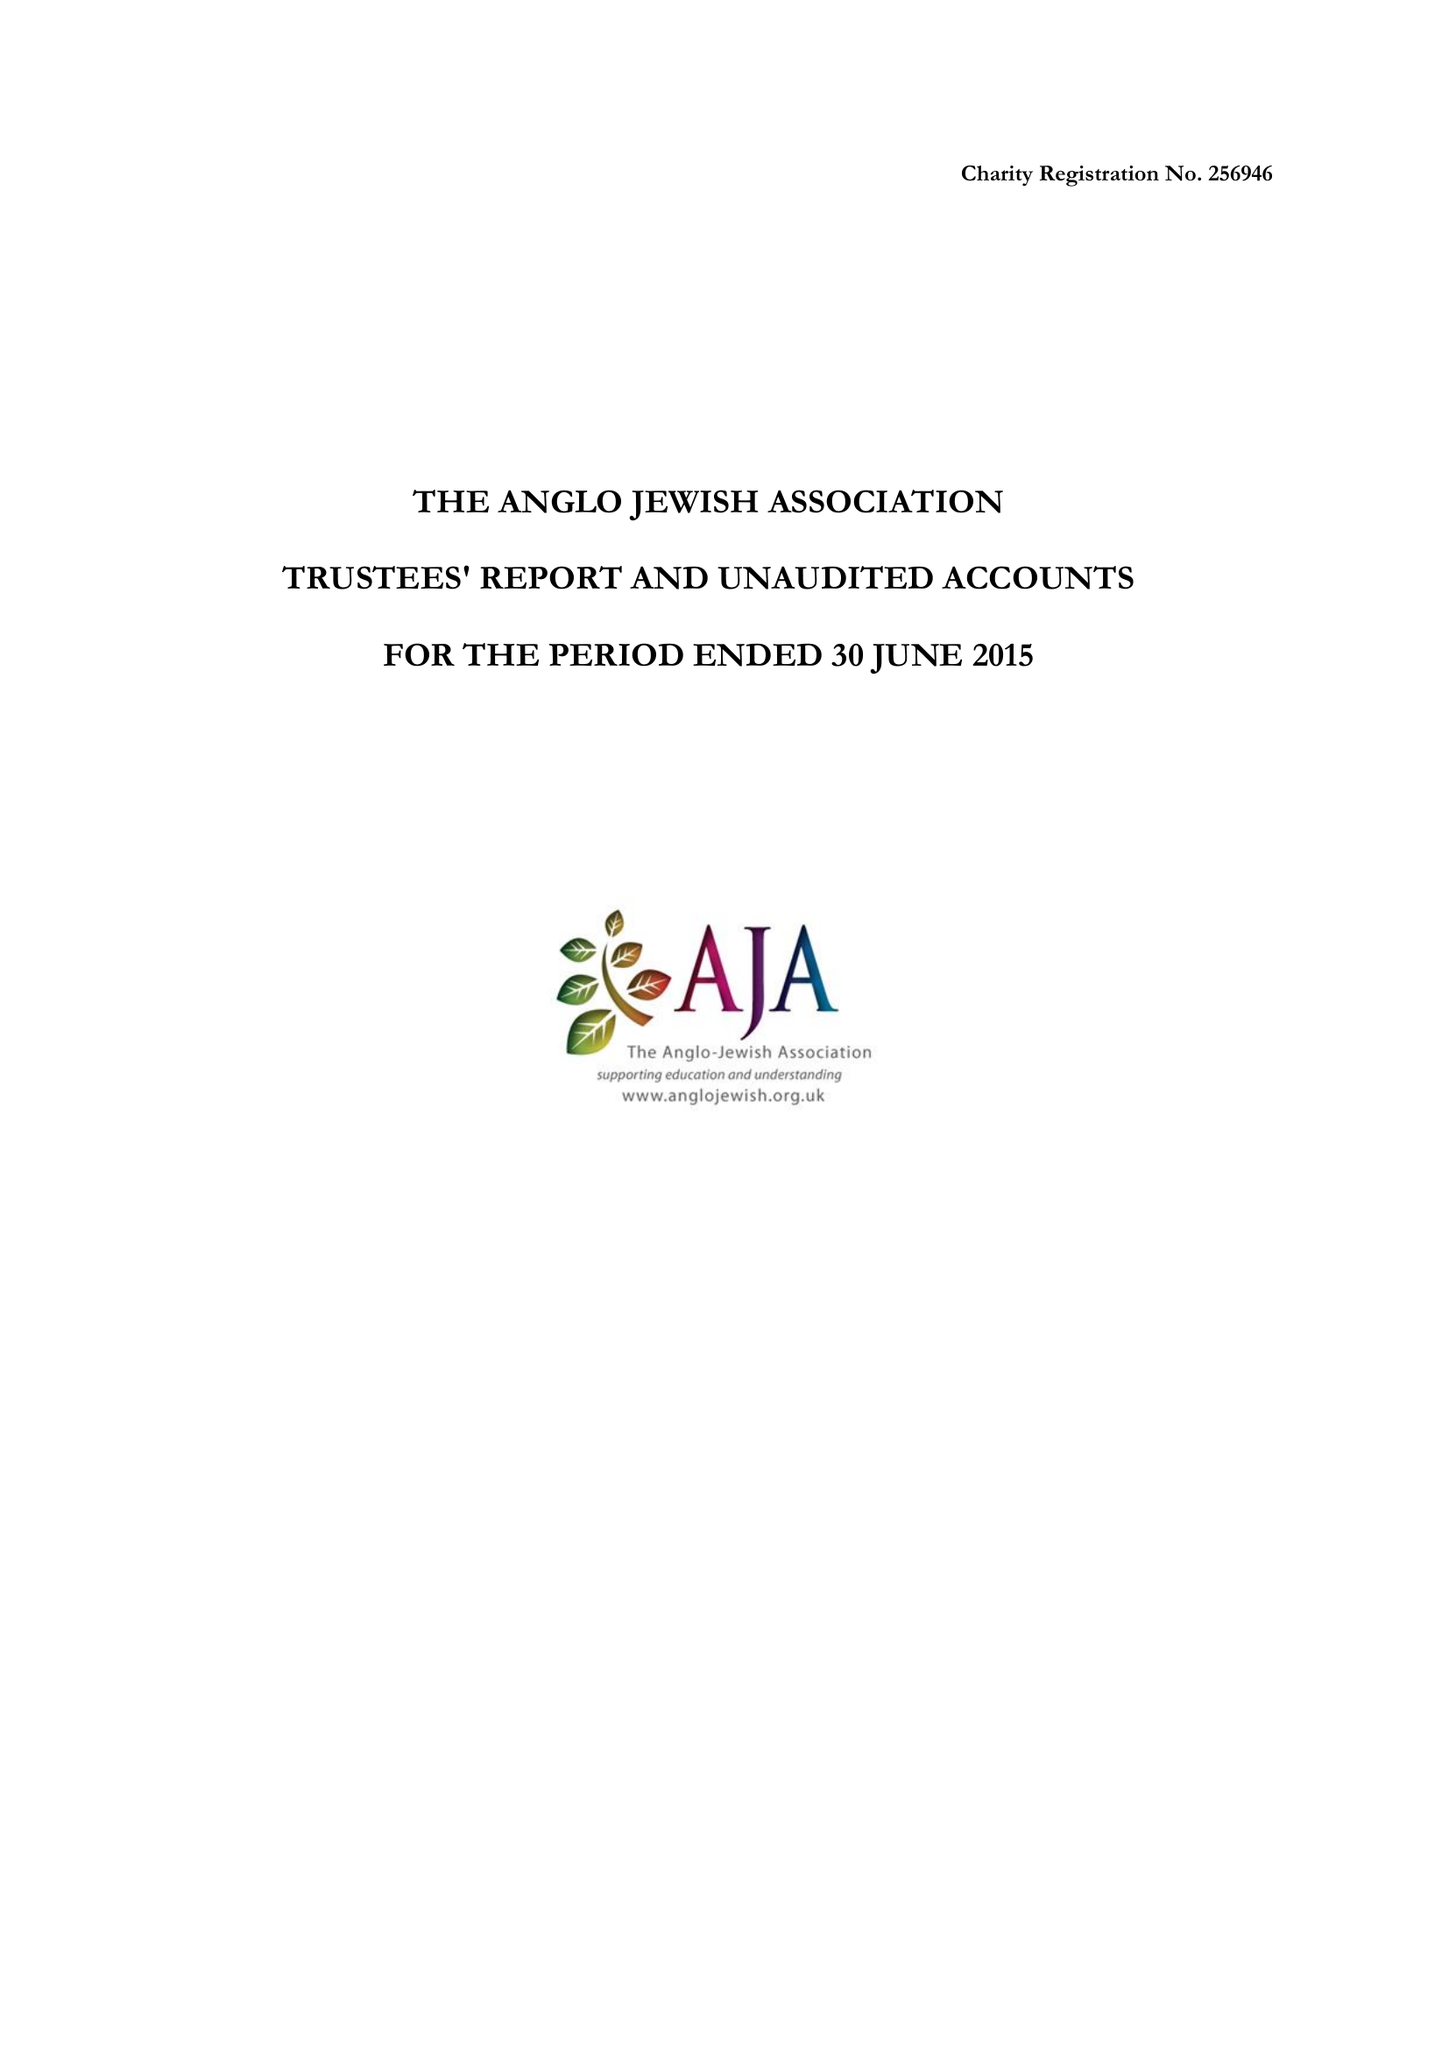What is the value for the spending_annually_in_british_pounds?
Answer the question using a single word or phrase. 234667.00 